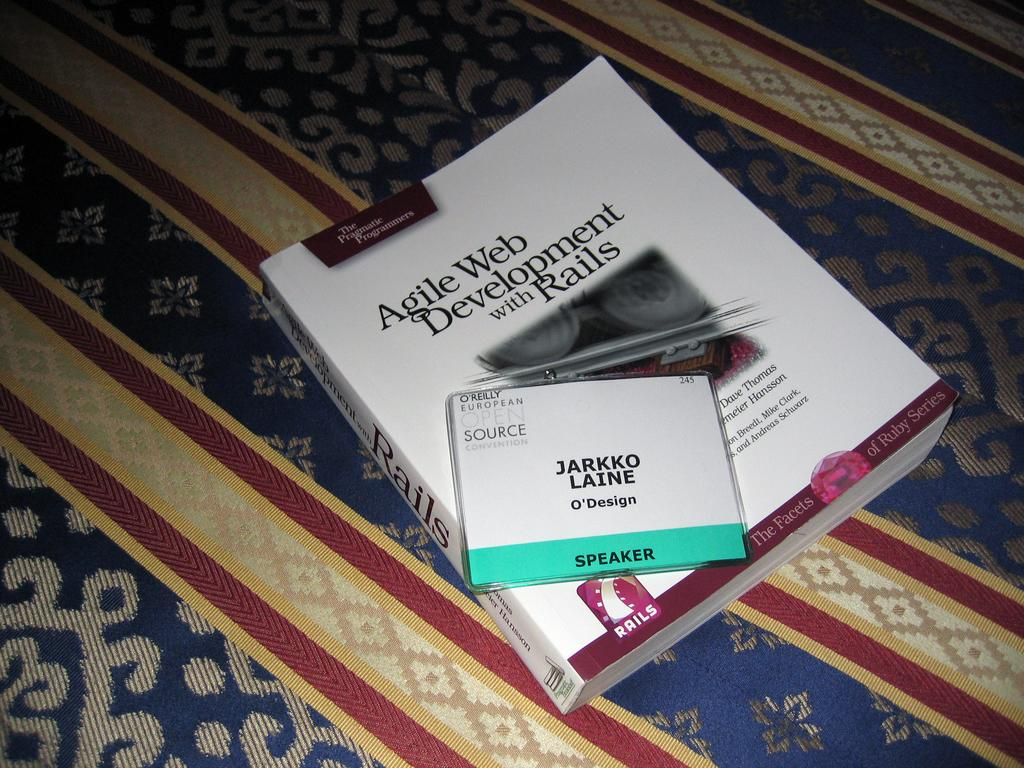Provide a one-sentence caption for the provided image. A book titled Agile Web Development with Rails is laying on a patterned surface. 